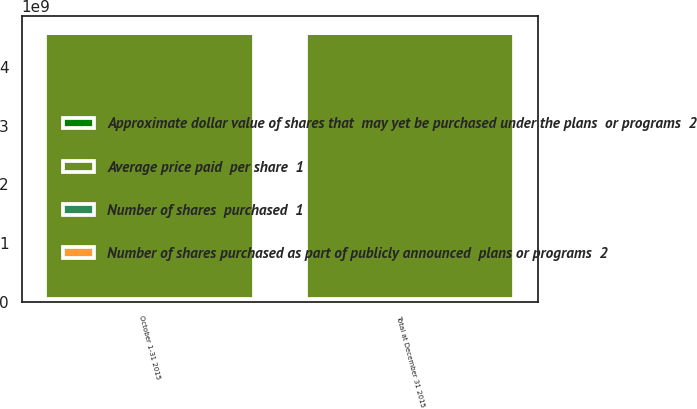Convert chart. <chart><loc_0><loc_0><loc_500><loc_500><stacked_bar_chart><ecel><fcel>October 1-31 2015<fcel>Total at December 31 2015<nl><fcel>Approximate dollar value of shares that  may yet be purchased under the plans  or programs  2<fcel>5.45137e+07<fcel>5.46655e+07<nl><fcel>Number of shares  purchased  1<fcel>18.77<fcel>18.77<nl><fcel>Number of shares purchased as part of publicly announced  plans or programs  2<fcel>5.45005e+07<fcel>5.45005e+07<nl><fcel>Average price paid  per share  1<fcel>4.52153e+09<fcel>4.52153e+09<nl></chart> 